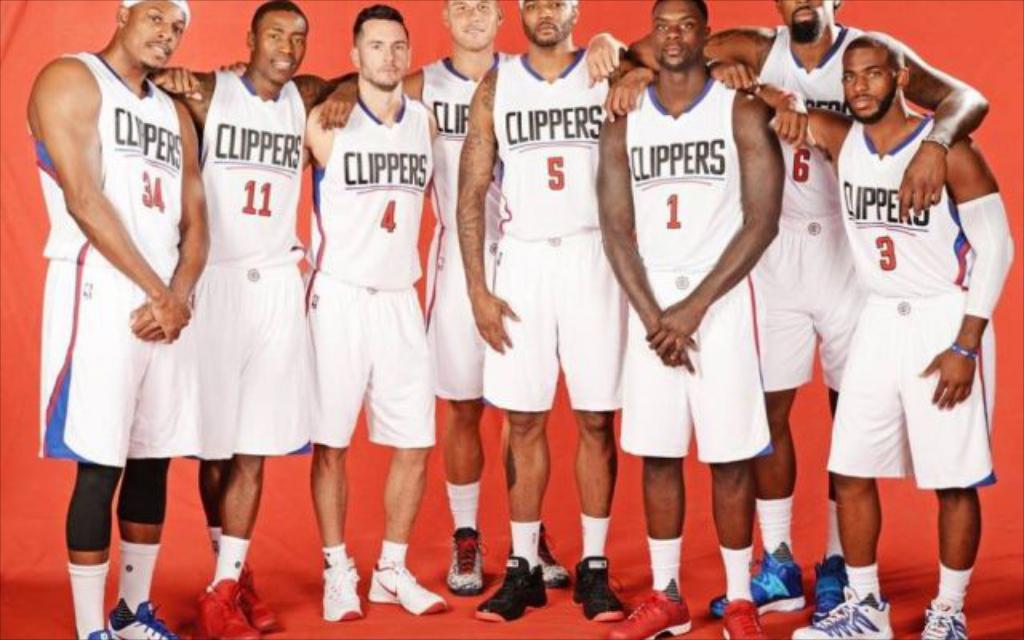<image>
Provide a brief description of the given image. Eight Clippers basketball players pose for a group photo. 